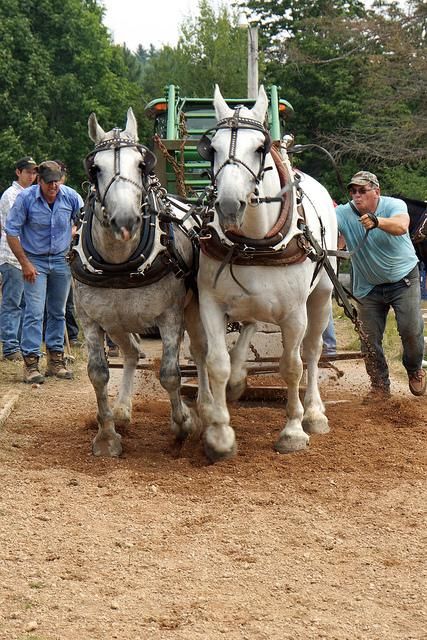What is the man on the right doing? plowing 